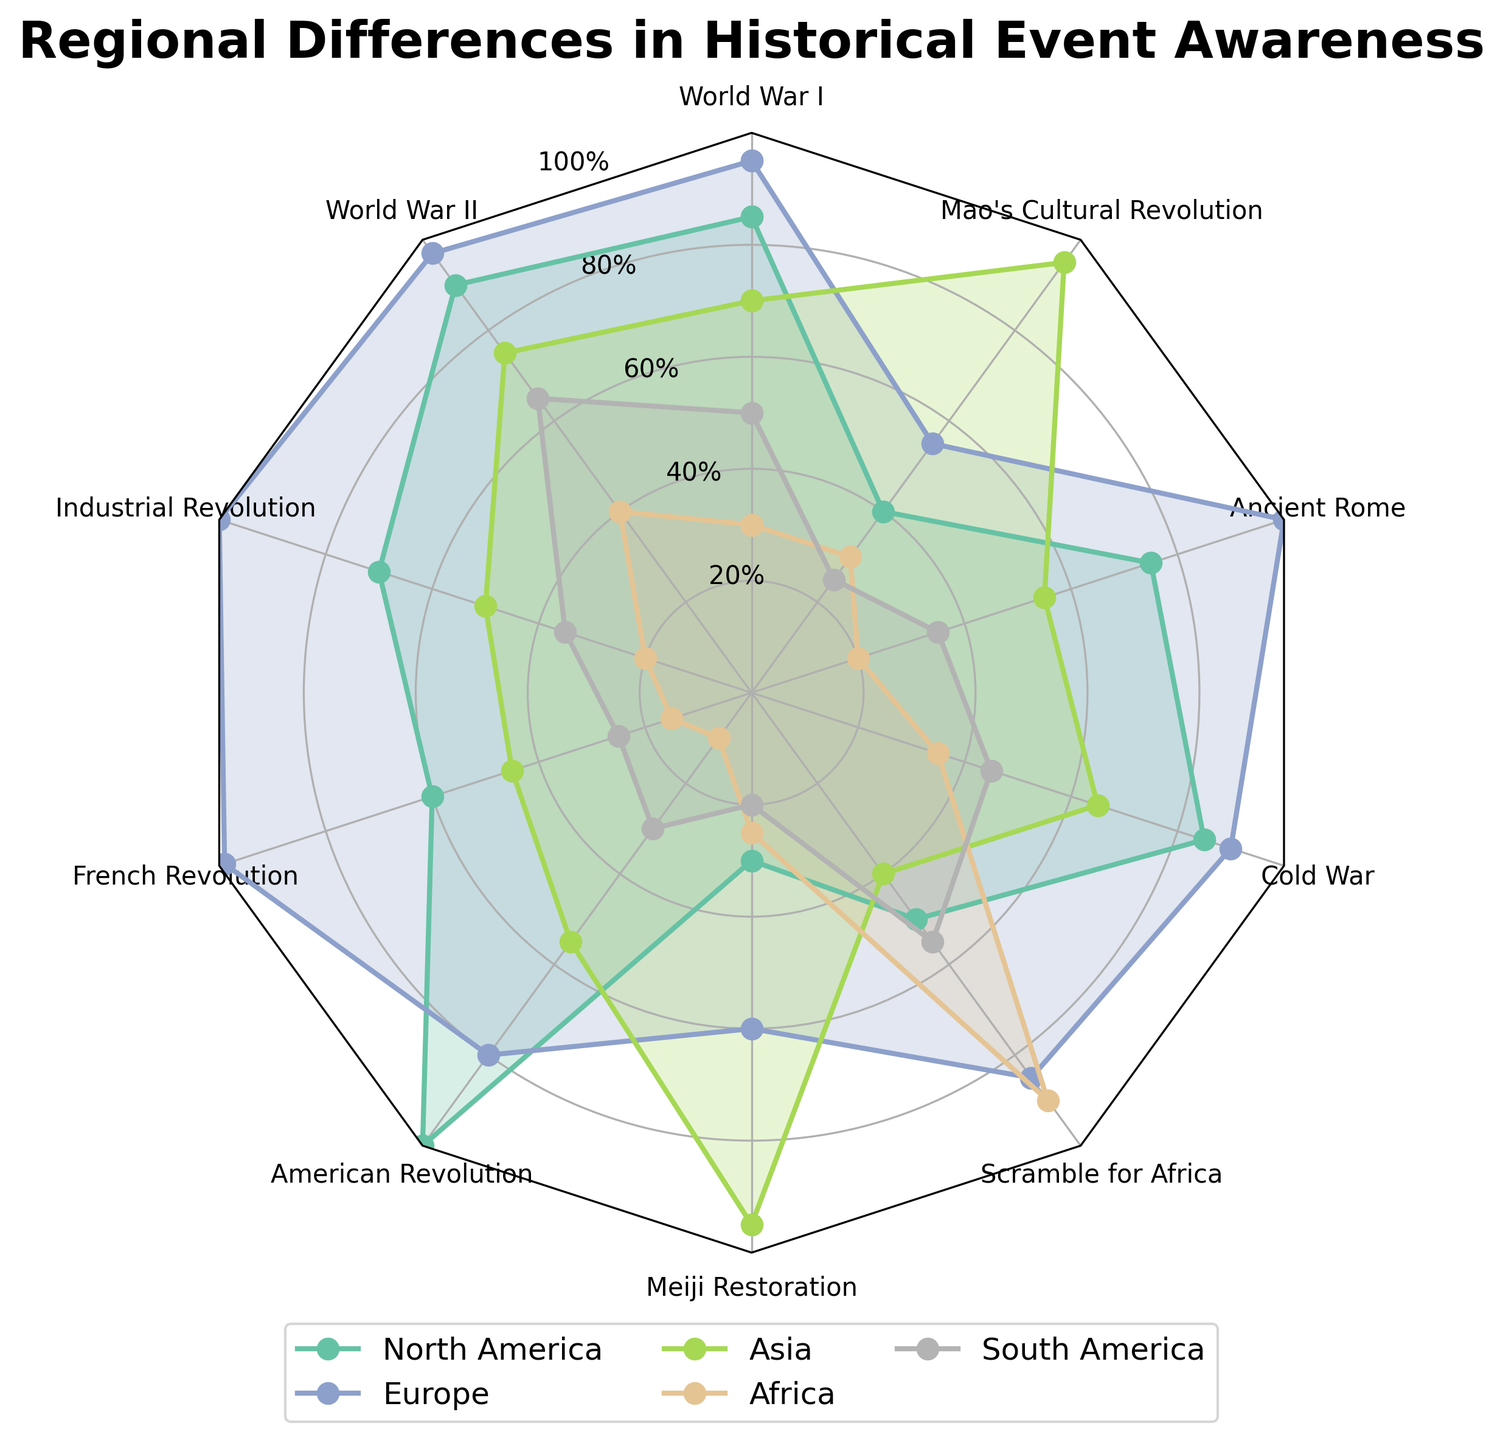What's the title of the figure? The title of the figure is located prominently at the top. It reads "Regional Differences in Historical Event Awareness."
Answer: Regional Differences in Historical Event Awareness How many regions are compared in the figure? The regions are shown in the legend located at the bottom of the chart. There are five regions listed: North America, Europe, Asia, Africa, and South America.
Answer: Five Which historical event has the highest awareness in Asia? The data points corresponding to Asia are shown on the radar chart, and the highest point (furthest away from the center) represents the highest awareness. The value for "Meiji Restoration" is at 95, which is the highest for Asia.
Answer: Meiji Restoration What is the average awareness of World War I across all regions? To find the average, sum the awareness values for World War I across all regions (85, 95, 70, 30, 50) and then divide by the number of regions (5). (85 + 95 + 70 + 30 + 50) / 5 = 330 / 5 = 66
Answer: 66 Which region has the lowest awareness of the American Revolution? Look for the data point corresponding to the American Revolution and find the lowest value among regions. Africa has the lowest value at 10.
Answer: Africa How does the awareness of the Cold War compare between Europe and North America? The values for the Cold War for Europe and North America can be compared directly on the radar chart. Europe is at 90, and North America is at 85, so Europe has a higher awareness.
Answer: Europe has higher awareness What is the median awareness score for the Meiji Restoration across all regions? To find the median, list the values in numerical order: 20, 25, 30, 60, 95. The middle value (third value in this case) is 30.
Answer: 30 For which historical event is there the greatest difference in awareness between North America and South America? Calculate the difference between North America and South America for each historical event and find the maximum difference. The differences are: World War I (35), World War II (25), Industrial Revolution (35), French Revolution (35), American Revolution (70), Meiji Restoration (10), Scramble for Africa (5), Cold War (40), Ancient Rome (40), and Mao's Cultural Revolution (15). The greatest difference is for the American Revolution (70).
Answer: American Revolution Which events have an awareness score above 90 in Europe? By examining the radar chart, the events with values above 90 for Europe are: World War I (95), World War II (97), Industrial Revolution (100), French Revolution (99), Cold War (90), and Ancient Rome (100).
Answer: World War I, World War II, Industrial Revolution, French Revolution, Cold War, Ancient Rome Is there any event where the awareness is equal in two or more regions? Look for overlapping values on the radar chart. One such instance is the Meiji Restoration, where both North America and Africa have an awareness score of 30.
Answer: Meiji Restoration 